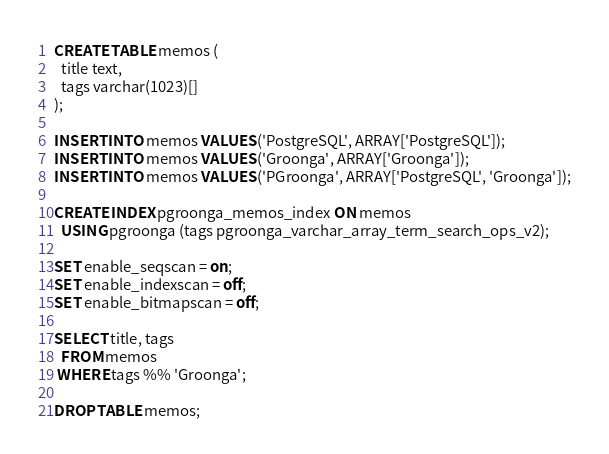<code> <loc_0><loc_0><loc_500><loc_500><_SQL_>CREATE TABLE memos (
  title text,
  tags varchar(1023)[]
);

INSERT INTO memos VALUES ('PostgreSQL', ARRAY['PostgreSQL']);
INSERT INTO memos VALUES ('Groonga', ARRAY['Groonga']);
INSERT INTO memos VALUES ('PGroonga', ARRAY['PostgreSQL', 'Groonga']);

CREATE INDEX pgroonga_memos_index ON memos
  USING pgroonga (tags pgroonga_varchar_array_term_search_ops_v2);

SET enable_seqscan = on;
SET enable_indexscan = off;
SET enable_bitmapscan = off;

SELECT title, tags
  FROM memos
 WHERE tags %% 'Groonga';

DROP TABLE memos;
</code> 